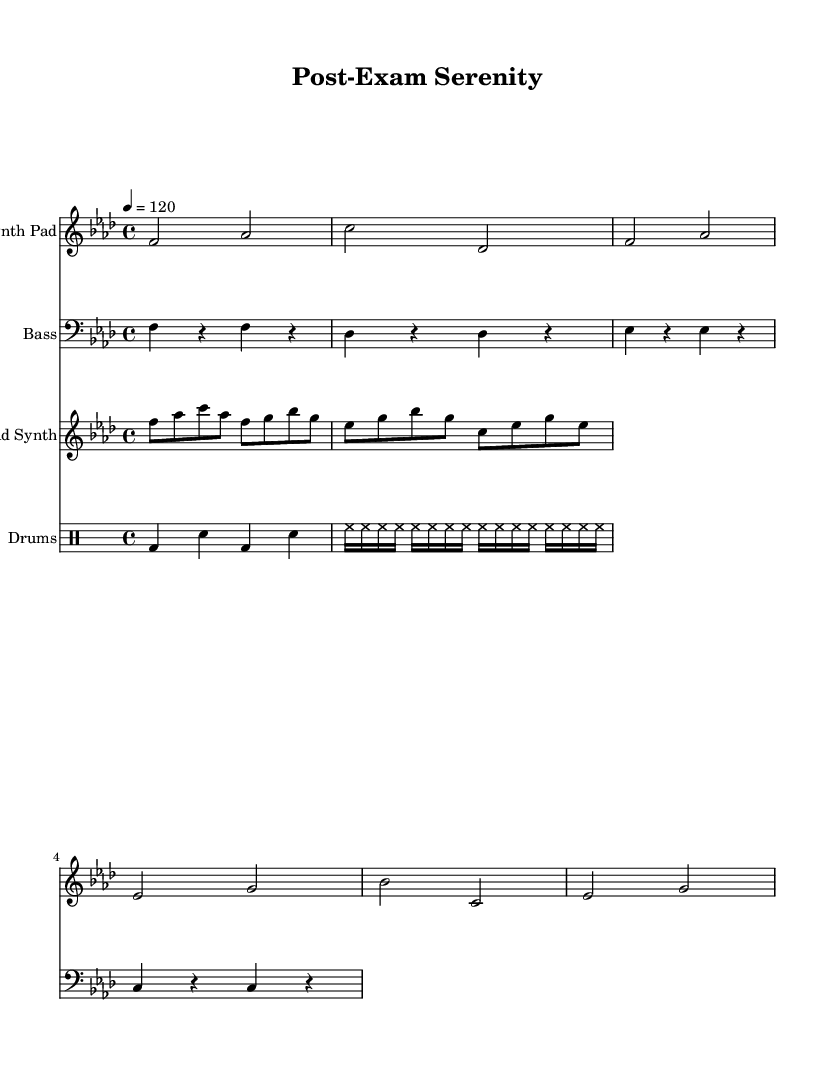What is the key signature of this music? The sheet music shows a key signature with four flats, indicating it is in F minor. F minor has the flats B♭, E♭, A♭, and D♭.
Answer: F minor What is the time signature of this piece? The time signature in the sheet music is 4/4, which indicates there are four beats per measure and a quarter note receives one beat.
Answer: 4/4 What is the tempo indicated for this piece? The tempo marking at the beginning indicates a speed of 120 beats per minute, which is a moderate pace suitable for deep house music.
Answer: 120 How many measures are in the synth pad part? The synth pad part contains four measures as counted by the bar lines, which separate the sections of music.
Answer: 4 What type of percussion is predominantly used in this music? The drum part uses a bass drum and snare drum pattern, which is typical in dance music to create a steady beat.
Answer: Bass drum and snare How does the melody in the lead synth relate to the chords in the synth pad? The melody in the lead synth closely follows the notes in the synth pad, harmonizing with the underlying chords while adding rhythmic complexity. This creates a layered and immersive sound characteristic of deep house music.
Answer: It harmonizes What genre is this music associated with? The term "deep house" found in the description suggests this piece is related to a genre known for its chill, melodic beats often used for relaxation.
Answer: Deep house 